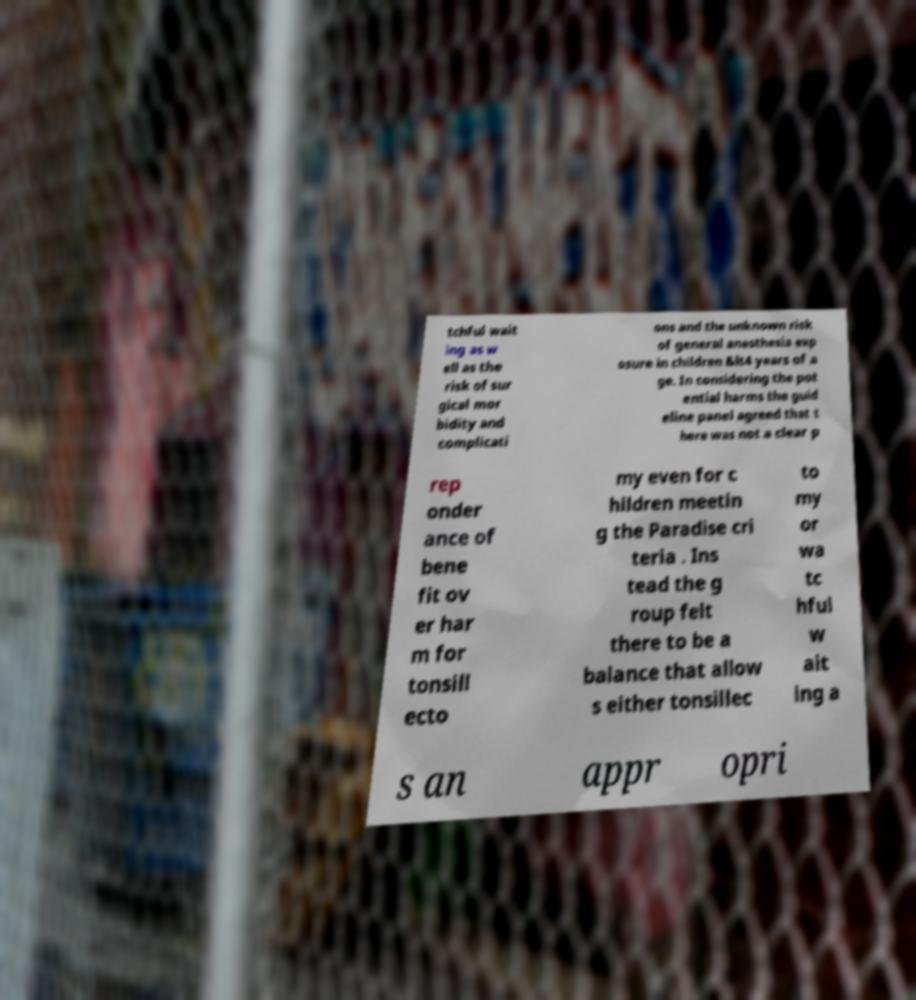Can you read and provide the text displayed in the image?This photo seems to have some interesting text. Can you extract and type it out for me? tchful wait ing as w ell as the risk of sur gical mor bidity and complicati ons and the unknown risk of general anesthesia exp osure in children &lt4 years of a ge. In considering the pot ential harms the guid eline panel agreed that t here was not a clear p rep onder ance of bene fit ov er har m for tonsill ecto my even for c hildren meetin g the Paradise cri teria . Ins tead the g roup felt there to be a balance that allow s either tonsillec to my or wa tc hful w ait ing a s an appr opri 